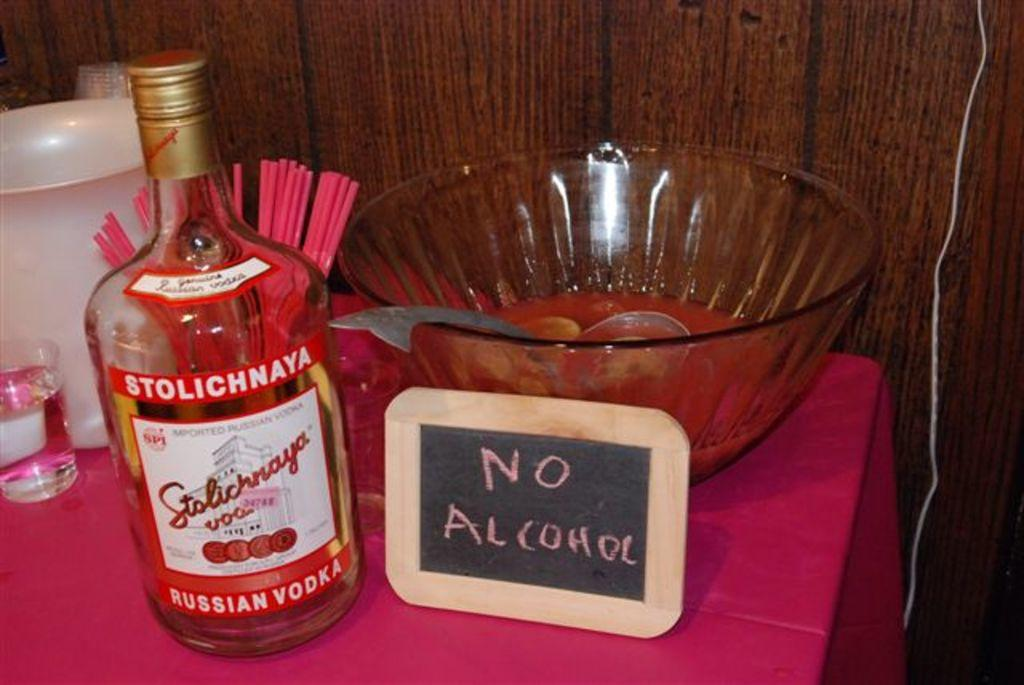<image>
Provide a brief description of the given image. A bottle of Russian vodka next to a sign that says no alcohol. 